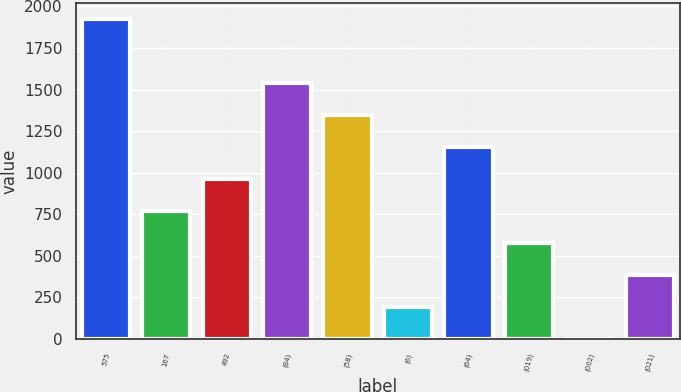Convert chart to OTSL. <chart><loc_0><loc_0><loc_500><loc_500><bar_chart><fcel>575<fcel>167<fcel>492<fcel>(84)<fcel>(58)<fcel>(6)<fcel>(64)<fcel>(019)<fcel>(002)<fcel>(021)<nl><fcel>1926<fcel>770.41<fcel>963.01<fcel>1540.81<fcel>1348.21<fcel>192.61<fcel>1155.61<fcel>577.81<fcel>0.01<fcel>385.21<nl></chart> 